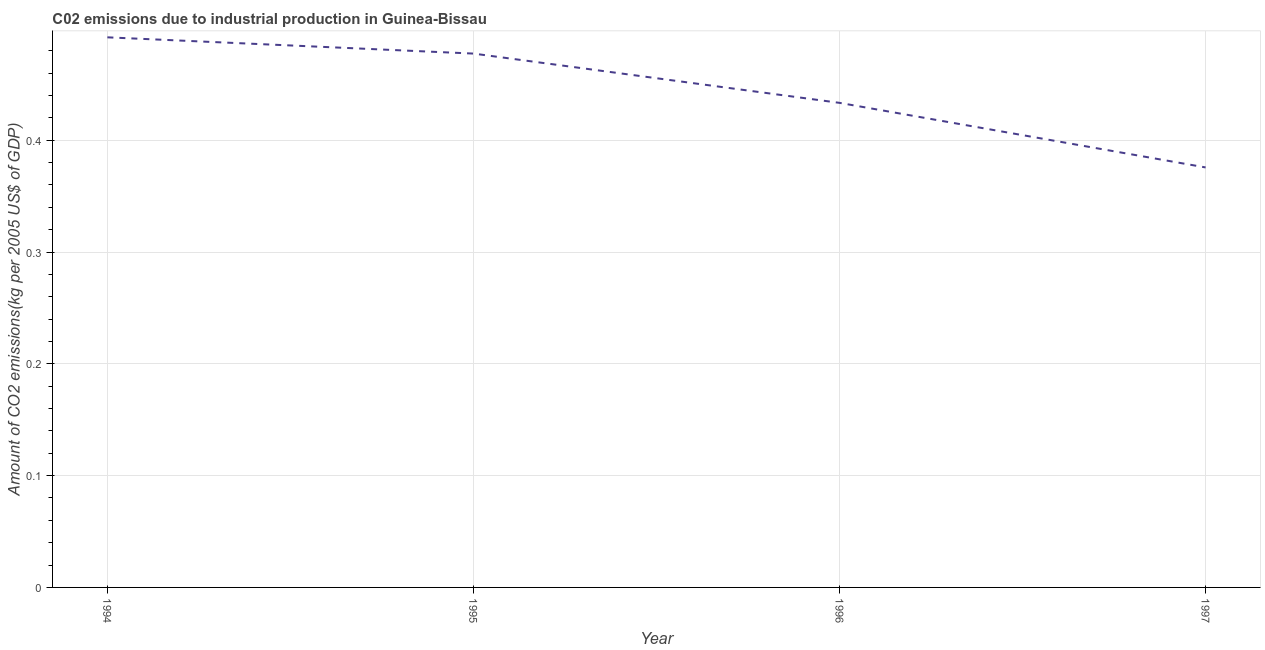What is the amount of co2 emissions in 1994?
Your answer should be compact. 0.49. Across all years, what is the maximum amount of co2 emissions?
Your response must be concise. 0.49. Across all years, what is the minimum amount of co2 emissions?
Offer a very short reply. 0.38. In which year was the amount of co2 emissions maximum?
Offer a terse response. 1994. What is the sum of the amount of co2 emissions?
Give a very brief answer. 1.78. What is the difference between the amount of co2 emissions in 1994 and 1996?
Keep it short and to the point. 0.06. What is the average amount of co2 emissions per year?
Offer a terse response. 0.44. What is the median amount of co2 emissions?
Provide a short and direct response. 0.46. What is the ratio of the amount of co2 emissions in 1994 to that in 1997?
Keep it short and to the point. 1.31. What is the difference between the highest and the second highest amount of co2 emissions?
Provide a short and direct response. 0.01. Is the sum of the amount of co2 emissions in 1994 and 1996 greater than the maximum amount of co2 emissions across all years?
Ensure brevity in your answer.  Yes. What is the difference between the highest and the lowest amount of co2 emissions?
Offer a terse response. 0.12. How many years are there in the graph?
Your answer should be very brief. 4. What is the difference between two consecutive major ticks on the Y-axis?
Your response must be concise. 0.1. Does the graph contain grids?
Keep it short and to the point. Yes. What is the title of the graph?
Offer a terse response. C02 emissions due to industrial production in Guinea-Bissau. What is the label or title of the Y-axis?
Provide a succinct answer. Amount of CO2 emissions(kg per 2005 US$ of GDP). What is the Amount of CO2 emissions(kg per 2005 US$ of GDP) of 1994?
Make the answer very short. 0.49. What is the Amount of CO2 emissions(kg per 2005 US$ of GDP) of 1995?
Give a very brief answer. 0.48. What is the Amount of CO2 emissions(kg per 2005 US$ of GDP) of 1996?
Make the answer very short. 0.43. What is the Amount of CO2 emissions(kg per 2005 US$ of GDP) of 1997?
Provide a short and direct response. 0.38. What is the difference between the Amount of CO2 emissions(kg per 2005 US$ of GDP) in 1994 and 1995?
Your response must be concise. 0.01. What is the difference between the Amount of CO2 emissions(kg per 2005 US$ of GDP) in 1994 and 1996?
Provide a succinct answer. 0.06. What is the difference between the Amount of CO2 emissions(kg per 2005 US$ of GDP) in 1994 and 1997?
Your response must be concise. 0.12. What is the difference between the Amount of CO2 emissions(kg per 2005 US$ of GDP) in 1995 and 1996?
Your response must be concise. 0.04. What is the difference between the Amount of CO2 emissions(kg per 2005 US$ of GDP) in 1995 and 1997?
Offer a very short reply. 0.1. What is the difference between the Amount of CO2 emissions(kg per 2005 US$ of GDP) in 1996 and 1997?
Keep it short and to the point. 0.06. What is the ratio of the Amount of CO2 emissions(kg per 2005 US$ of GDP) in 1994 to that in 1996?
Offer a terse response. 1.14. What is the ratio of the Amount of CO2 emissions(kg per 2005 US$ of GDP) in 1994 to that in 1997?
Offer a terse response. 1.31. What is the ratio of the Amount of CO2 emissions(kg per 2005 US$ of GDP) in 1995 to that in 1996?
Offer a terse response. 1.1. What is the ratio of the Amount of CO2 emissions(kg per 2005 US$ of GDP) in 1995 to that in 1997?
Offer a very short reply. 1.27. What is the ratio of the Amount of CO2 emissions(kg per 2005 US$ of GDP) in 1996 to that in 1997?
Give a very brief answer. 1.15. 